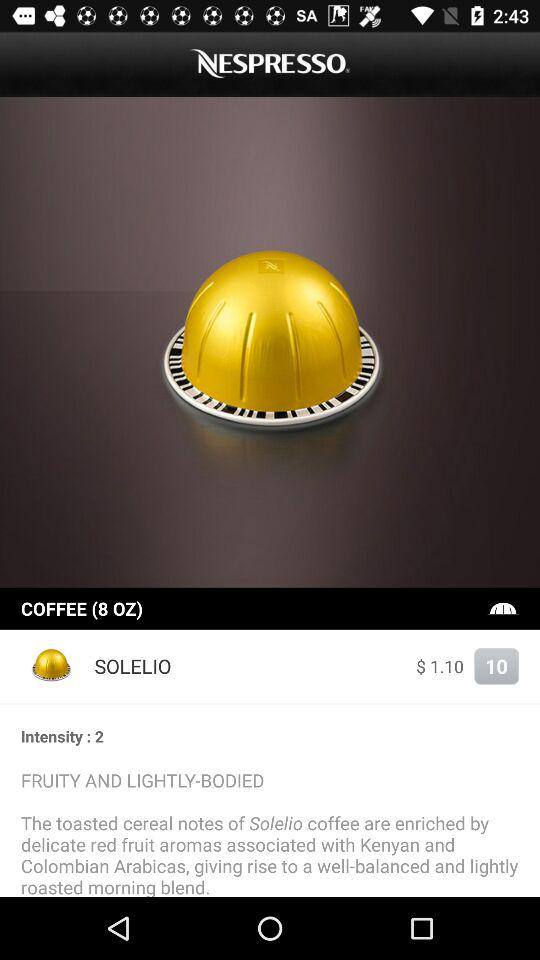What is the price of "SOLELIO"? The price of "SOLELIO" is $1.10. 